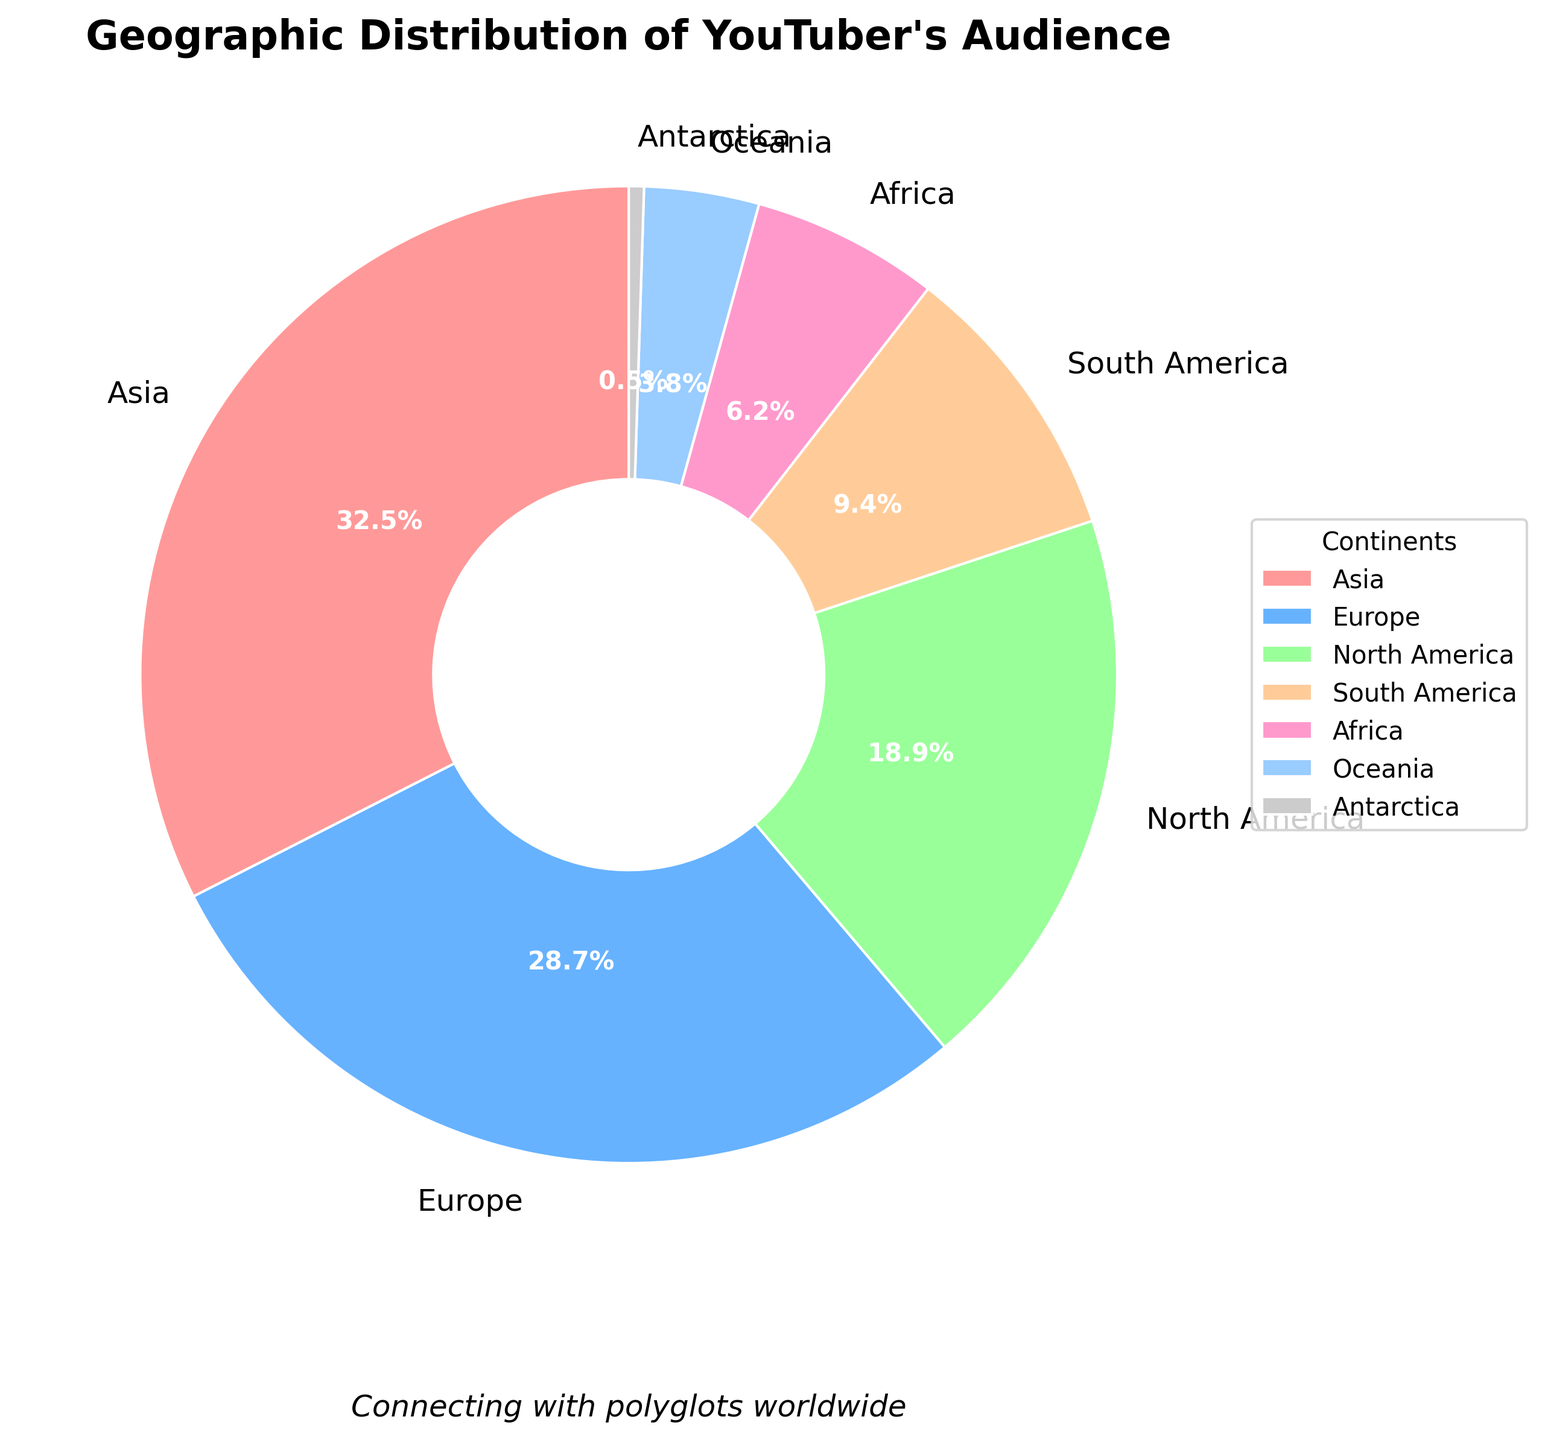What is the continent with the highest percentage of the audience? From the pie chart, the segment representing Asia occupies the largest portion. It's labeled with the highest percentage, which is 32.5%.
Answer: Asia Which continents have a lower percentage of the audience than North America? North America has 18.9%. The segments representing South America, Africa, Oceania, and Antarctica have lower percentages than North America. Specifically, they are 9.4%, 6.2%, 3.8%, and 0.5% respectively.
Answer: Africa, Antarctica, South America, Oceania How much greater is the percentage of the audience in Europe compared to Oceania? Europe has 28.7% and Oceania has 3.8%. To find the difference, we subtract the percentage for Oceania from that of Europe: 28.7% - 3.8% = 24.9%.
Answer: 24.9% What is the combined percentage of the audience from Africa and Oceania? The percentage for Africa is 6.2% and for Oceania it's 3.8%. Adding these together: 6.2% + 3.8% = 10.0%.
Answer: 10.0% Which continent has the smallest proportion of the audience? The smallest segment on the pie chart is labeled Antarctica, with a percentage of 0.5%.
Answer: Antarctica If you combine the percentages of Europe and North America, how does it compare to the percentage of Asia? Europe has 28.7% and North America has 18.9%. Adding them together: 28.7% + 18.9% = 47.6%. Asia has 32.5%. Comparing the two sums, 47.6% is greater than 32.5%.
Answer: Greater What is the average percentage of the audience across all continents? There are 7 continents with the following percentages: 32.5, 28.7, 18.9, 9.4, 6.2, 3.8, and 0.5. The sum of these percentages is 100%. To find the average: 100% / 7 = approximately 14.3%.
Answer: 14.3% Which continent's audience percentage is closest to 10%? The pie chart shows South America with 9.4%, which is the closest to 10%.
Answer: South America 